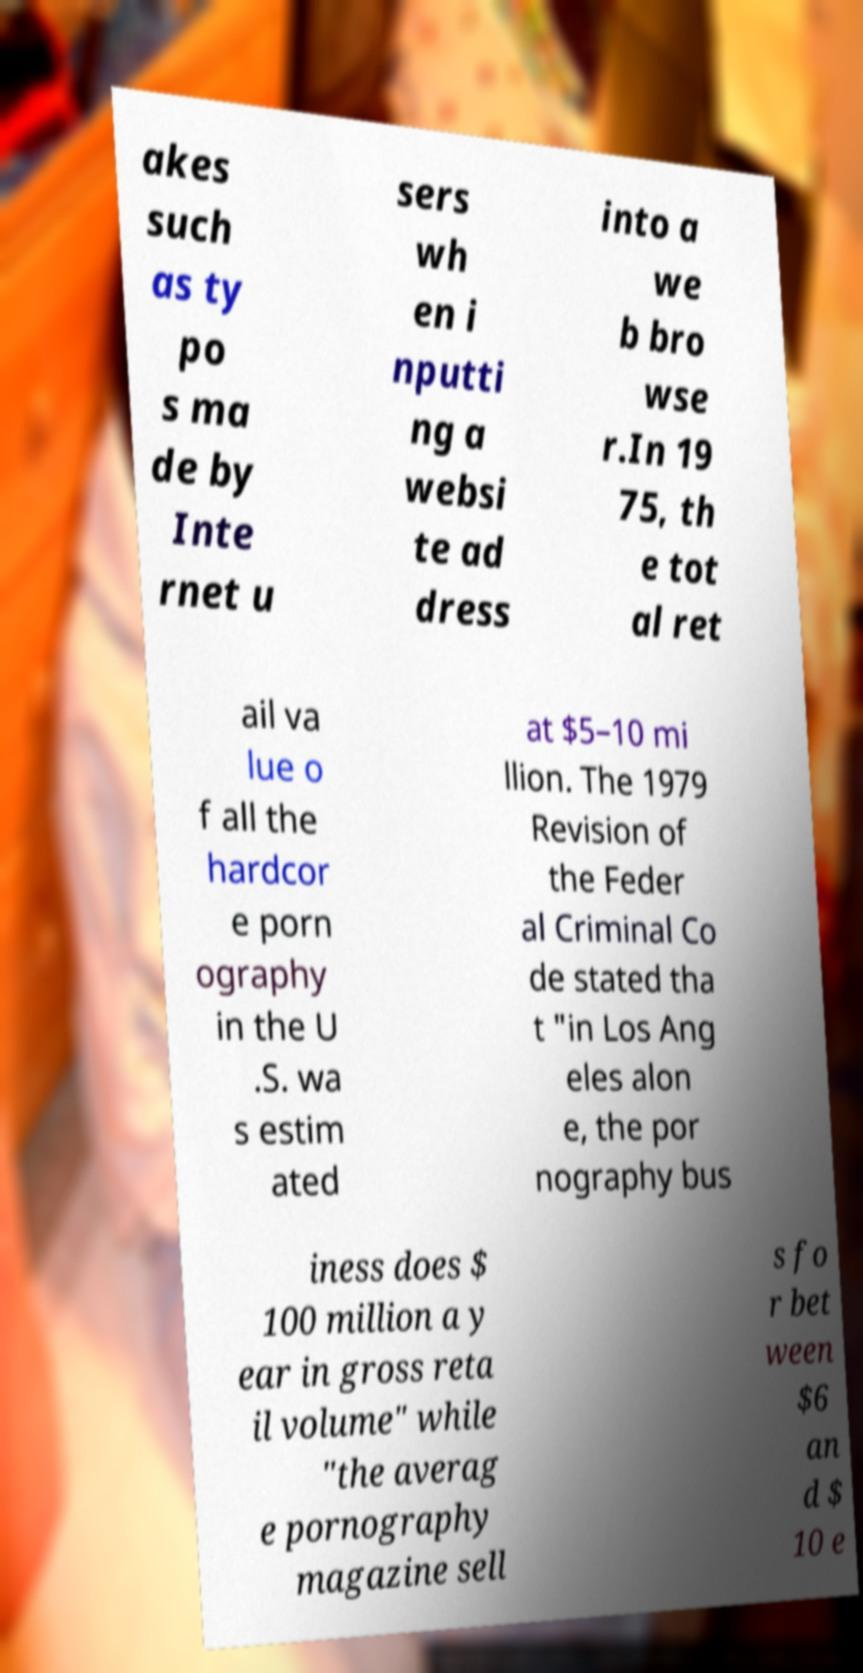For documentation purposes, I need the text within this image transcribed. Could you provide that? akes such as ty po s ma de by Inte rnet u sers wh en i nputti ng a websi te ad dress into a we b bro wse r.In 19 75, th e tot al ret ail va lue o f all the hardcor e porn ography in the U .S. wa s estim ated at $5–10 mi llion. The 1979 Revision of the Feder al Criminal Co de stated tha t "in Los Ang eles alon e, the por nography bus iness does $ 100 million a y ear in gross reta il volume" while "the averag e pornography magazine sell s fo r bet ween $6 an d $ 10 e 